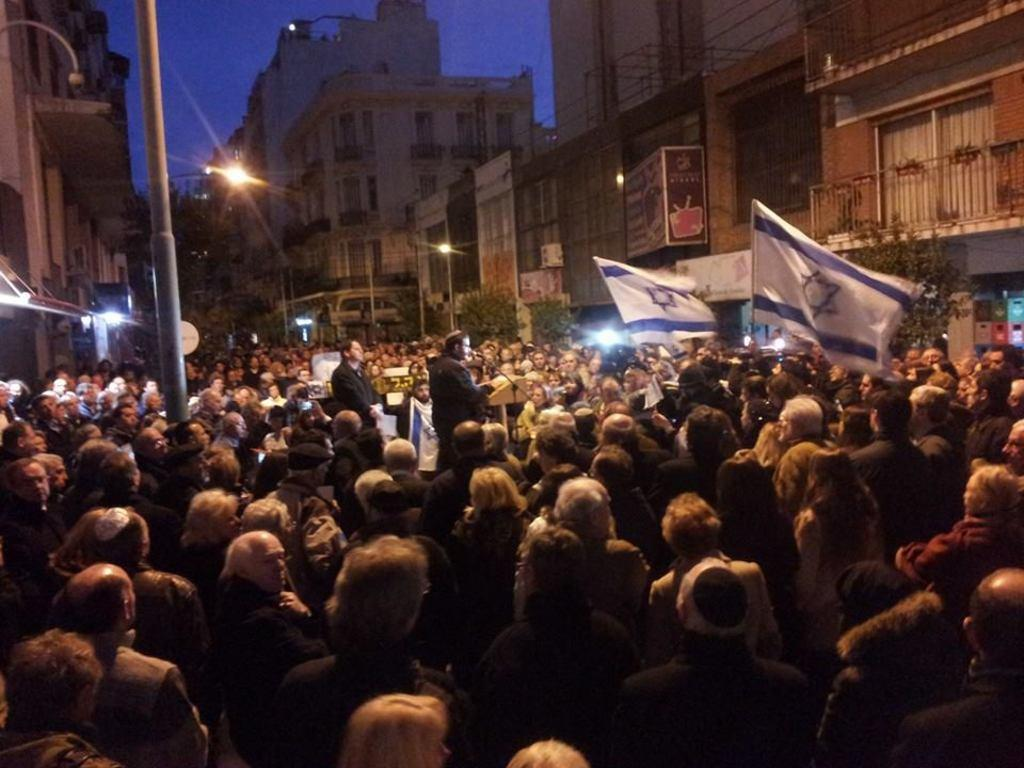What is located in the center of the image? There are people in the center of the image. What can be seen in the background of the image? There are buildings in the background of the image. What object is present in the image that is typically used for support or guidance? There is a pole in the image. What type of lighting fixture is visible in the image? There is a street light in the image. What is visible at the top of the image? The sky is visible at the top of the image. What type of mouth can be seen on the pole in the image? There is no mouth present on the pole in the image. What part of the human body is responsible for thinking and decision-making, and can it be seen in the image? The brain is not visible in the image, and it is not a part of the image. 